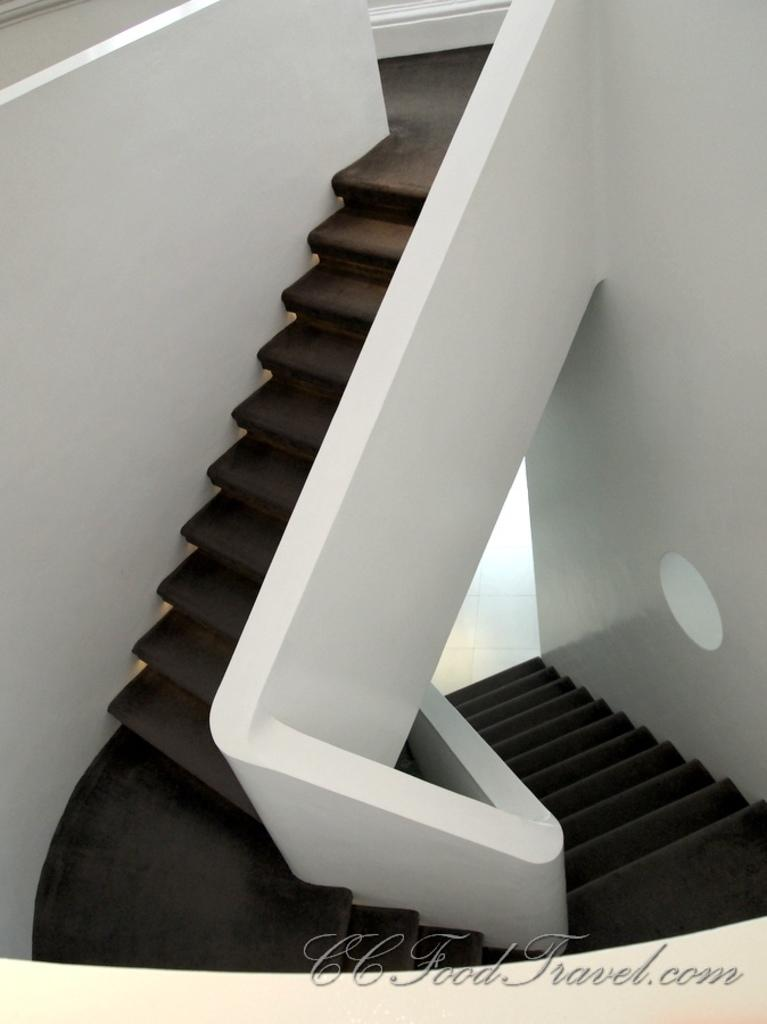What type of structure is present in the image? There is a staircase in the image. What else can be seen in the image besides the staircase? There is a wall in the image. Is there any text present in the image? Yes, there is text at the bottom of the image. Can you see the sky in the image? The provided facts do not mention the sky, so it cannot be determined if it is visible in the image. Is there any land visible in the image? The provided facts do not mention land, so it cannot be determined if it is visible in the image. 